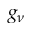<formula> <loc_0><loc_0><loc_500><loc_500>g _ { \nu }</formula> 